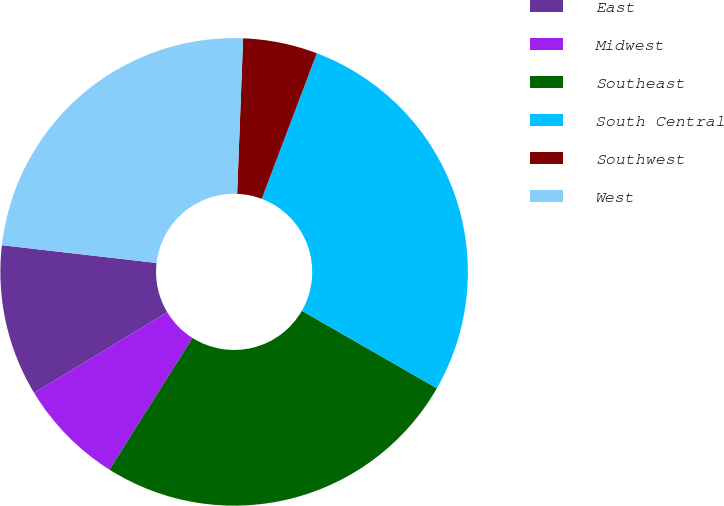Convert chart to OTSL. <chart><loc_0><loc_0><loc_500><loc_500><pie_chart><fcel>East<fcel>Midwest<fcel>Southeast<fcel>South Central<fcel>Southwest<fcel>West<nl><fcel>10.48%<fcel>7.39%<fcel>25.66%<fcel>27.54%<fcel>5.14%<fcel>23.79%<nl></chart> 